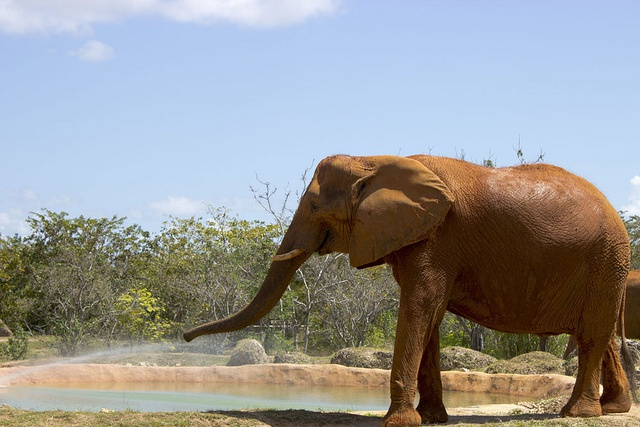Describe the objects in this image and their specific colors. I can see a elephant in lavender, black, maroon, and gray tones in this image. 